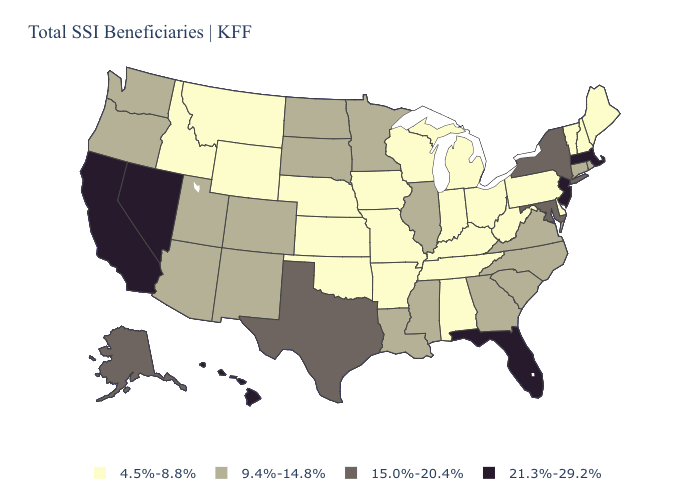Does Oregon have the lowest value in the West?
Be succinct. No. Does New Hampshire have a lower value than Oklahoma?
Give a very brief answer. No. Name the states that have a value in the range 4.5%-8.8%?
Short answer required. Alabama, Arkansas, Delaware, Idaho, Indiana, Iowa, Kansas, Kentucky, Maine, Michigan, Missouri, Montana, Nebraska, New Hampshire, Ohio, Oklahoma, Pennsylvania, Tennessee, Vermont, West Virginia, Wisconsin, Wyoming. Does Iowa have the same value as Georgia?
Answer briefly. No. What is the value of Montana?
Give a very brief answer. 4.5%-8.8%. What is the value of New Mexico?
Answer briefly. 9.4%-14.8%. Name the states that have a value in the range 15.0%-20.4%?
Be succinct. Alaska, Maryland, New York, Texas. Among the states that border New Hampshire , which have the lowest value?
Quick response, please. Maine, Vermont. What is the value of Missouri?
Short answer required. 4.5%-8.8%. What is the value of Nevada?
Be succinct. 21.3%-29.2%. What is the highest value in the West ?
Short answer required. 21.3%-29.2%. Which states have the lowest value in the USA?
Concise answer only. Alabama, Arkansas, Delaware, Idaho, Indiana, Iowa, Kansas, Kentucky, Maine, Michigan, Missouri, Montana, Nebraska, New Hampshire, Ohio, Oklahoma, Pennsylvania, Tennessee, Vermont, West Virginia, Wisconsin, Wyoming. Which states have the lowest value in the West?
Answer briefly. Idaho, Montana, Wyoming. Name the states that have a value in the range 4.5%-8.8%?
Concise answer only. Alabama, Arkansas, Delaware, Idaho, Indiana, Iowa, Kansas, Kentucky, Maine, Michigan, Missouri, Montana, Nebraska, New Hampshire, Ohio, Oklahoma, Pennsylvania, Tennessee, Vermont, West Virginia, Wisconsin, Wyoming. What is the value of Iowa?
Quick response, please. 4.5%-8.8%. 